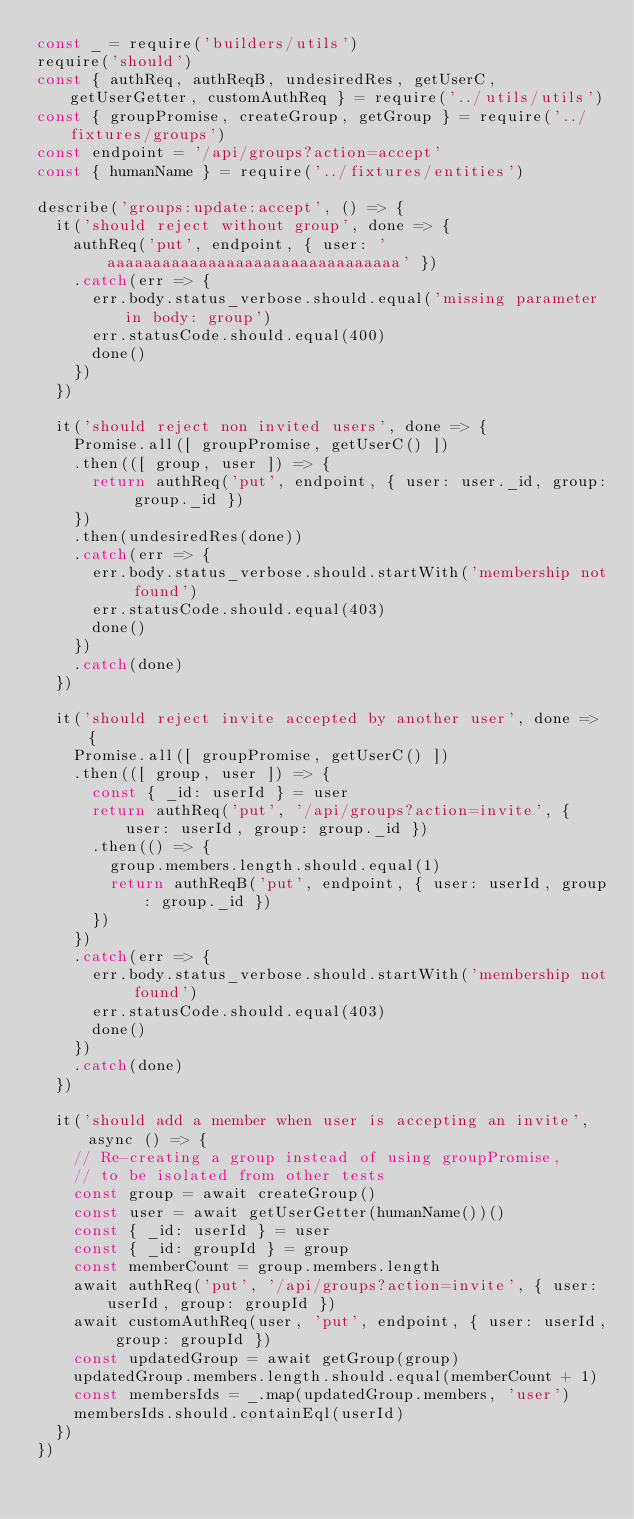<code> <loc_0><loc_0><loc_500><loc_500><_JavaScript_>const _ = require('builders/utils')
require('should')
const { authReq, authReqB, undesiredRes, getUserC, getUserGetter, customAuthReq } = require('../utils/utils')
const { groupPromise, createGroup, getGroup } = require('../fixtures/groups')
const endpoint = '/api/groups?action=accept'
const { humanName } = require('../fixtures/entities')

describe('groups:update:accept', () => {
  it('should reject without group', done => {
    authReq('put', endpoint, { user: 'aaaaaaaaaaaaaaaaaaaaaaaaaaaaaaaa' })
    .catch(err => {
      err.body.status_verbose.should.equal('missing parameter in body: group')
      err.statusCode.should.equal(400)
      done()
    })
  })

  it('should reject non invited users', done => {
    Promise.all([ groupPromise, getUserC() ])
    .then(([ group, user ]) => {
      return authReq('put', endpoint, { user: user._id, group: group._id })
    })
    .then(undesiredRes(done))
    .catch(err => {
      err.body.status_verbose.should.startWith('membership not found')
      err.statusCode.should.equal(403)
      done()
    })
    .catch(done)
  })

  it('should reject invite accepted by another user', done => {
    Promise.all([ groupPromise, getUserC() ])
    .then(([ group, user ]) => {
      const { _id: userId } = user
      return authReq('put', '/api/groups?action=invite', { user: userId, group: group._id })
      .then(() => {
        group.members.length.should.equal(1)
        return authReqB('put', endpoint, { user: userId, group: group._id })
      })
    })
    .catch(err => {
      err.body.status_verbose.should.startWith('membership not found')
      err.statusCode.should.equal(403)
      done()
    })
    .catch(done)
  })

  it('should add a member when user is accepting an invite', async () => {
    // Re-creating a group instead of using groupPromise,
    // to be isolated from other tests
    const group = await createGroup()
    const user = await getUserGetter(humanName())()
    const { _id: userId } = user
    const { _id: groupId } = group
    const memberCount = group.members.length
    await authReq('put', '/api/groups?action=invite', { user: userId, group: groupId })
    await customAuthReq(user, 'put', endpoint, { user: userId, group: groupId })
    const updatedGroup = await getGroup(group)
    updatedGroup.members.length.should.equal(memberCount + 1)
    const membersIds = _.map(updatedGroup.members, 'user')
    membersIds.should.containEql(userId)
  })
})
</code> 